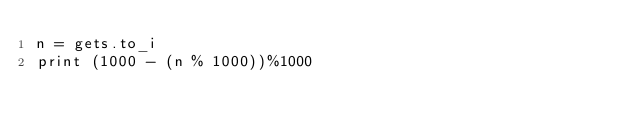Convert code to text. <code><loc_0><loc_0><loc_500><loc_500><_Ruby_>n = gets.to_i
print (1000 - (n % 1000))%1000</code> 